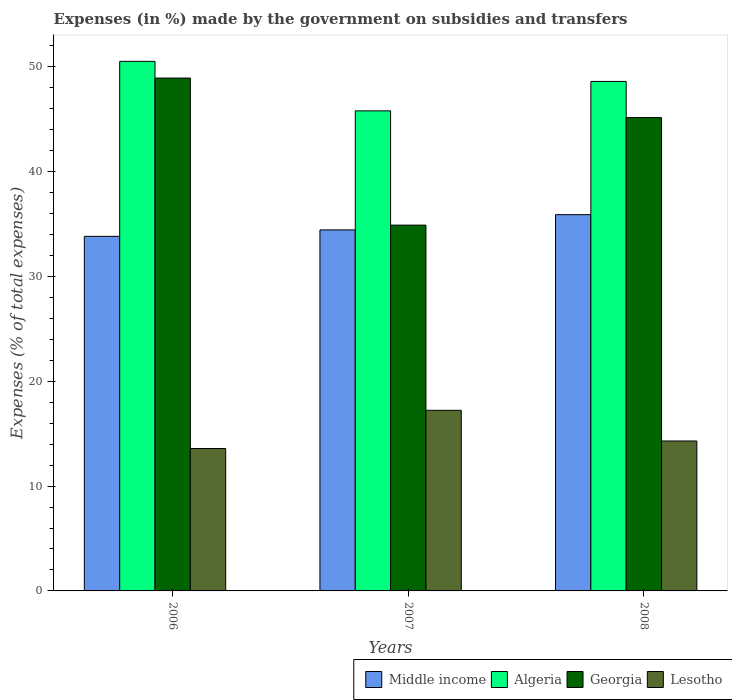How many different coloured bars are there?
Make the answer very short. 4. Are the number of bars per tick equal to the number of legend labels?
Give a very brief answer. Yes. How many bars are there on the 3rd tick from the left?
Offer a terse response. 4. How many bars are there on the 3rd tick from the right?
Keep it short and to the point. 4. What is the percentage of expenses made by the government on subsidies and transfers in Middle income in 2008?
Your response must be concise. 35.88. Across all years, what is the maximum percentage of expenses made by the government on subsidies and transfers in Algeria?
Your answer should be very brief. 50.5. Across all years, what is the minimum percentage of expenses made by the government on subsidies and transfers in Georgia?
Ensure brevity in your answer.  34.89. In which year was the percentage of expenses made by the government on subsidies and transfers in Algeria minimum?
Your answer should be very brief. 2007. What is the total percentage of expenses made by the government on subsidies and transfers in Georgia in the graph?
Keep it short and to the point. 128.94. What is the difference between the percentage of expenses made by the government on subsidies and transfers in Middle income in 2006 and that in 2008?
Make the answer very short. -2.07. What is the difference between the percentage of expenses made by the government on subsidies and transfers in Algeria in 2008 and the percentage of expenses made by the government on subsidies and transfers in Georgia in 2006?
Offer a terse response. -0.32. What is the average percentage of expenses made by the government on subsidies and transfers in Georgia per year?
Keep it short and to the point. 42.98. In the year 2006, what is the difference between the percentage of expenses made by the government on subsidies and transfers in Middle income and percentage of expenses made by the government on subsidies and transfers in Lesotho?
Offer a very short reply. 20.24. In how many years, is the percentage of expenses made by the government on subsidies and transfers in Georgia greater than 10 %?
Make the answer very short. 3. What is the ratio of the percentage of expenses made by the government on subsidies and transfers in Algeria in 2006 to that in 2008?
Your answer should be very brief. 1.04. Is the percentage of expenses made by the government on subsidies and transfers in Georgia in 2007 less than that in 2008?
Provide a short and direct response. Yes. Is the difference between the percentage of expenses made by the government on subsidies and transfers in Middle income in 2006 and 2007 greater than the difference between the percentage of expenses made by the government on subsidies and transfers in Lesotho in 2006 and 2007?
Keep it short and to the point. Yes. What is the difference between the highest and the second highest percentage of expenses made by the government on subsidies and transfers in Lesotho?
Your answer should be compact. 2.92. What is the difference between the highest and the lowest percentage of expenses made by the government on subsidies and transfers in Georgia?
Provide a succinct answer. 14.03. In how many years, is the percentage of expenses made by the government on subsidies and transfers in Georgia greater than the average percentage of expenses made by the government on subsidies and transfers in Georgia taken over all years?
Give a very brief answer. 2. What does the 1st bar from the left in 2008 represents?
Offer a terse response. Middle income. How many years are there in the graph?
Provide a succinct answer. 3. What is the difference between two consecutive major ticks on the Y-axis?
Ensure brevity in your answer.  10. Does the graph contain any zero values?
Provide a succinct answer. No. Does the graph contain grids?
Offer a very short reply. No. How many legend labels are there?
Offer a very short reply. 4. How are the legend labels stacked?
Keep it short and to the point. Horizontal. What is the title of the graph?
Your response must be concise. Expenses (in %) made by the government on subsidies and transfers. What is the label or title of the X-axis?
Your answer should be very brief. Years. What is the label or title of the Y-axis?
Give a very brief answer. Expenses (% of total expenses). What is the Expenses (% of total expenses) of Middle income in 2006?
Your response must be concise. 33.82. What is the Expenses (% of total expenses) in Algeria in 2006?
Your answer should be very brief. 50.5. What is the Expenses (% of total expenses) in Georgia in 2006?
Keep it short and to the point. 48.91. What is the Expenses (% of total expenses) in Lesotho in 2006?
Offer a terse response. 13.58. What is the Expenses (% of total expenses) in Middle income in 2007?
Ensure brevity in your answer.  34.43. What is the Expenses (% of total expenses) of Algeria in 2007?
Offer a very short reply. 45.78. What is the Expenses (% of total expenses) of Georgia in 2007?
Give a very brief answer. 34.89. What is the Expenses (% of total expenses) in Lesotho in 2007?
Your response must be concise. 17.23. What is the Expenses (% of total expenses) in Middle income in 2008?
Provide a short and direct response. 35.88. What is the Expenses (% of total expenses) of Algeria in 2008?
Provide a short and direct response. 48.59. What is the Expenses (% of total expenses) in Georgia in 2008?
Your answer should be very brief. 45.14. What is the Expenses (% of total expenses) of Lesotho in 2008?
Your answer should be compact. 14.3. Across all years, what is the maximum Expenses (% of total expenses) in Middle income?
Provide a short and direct response. 35.88. Across all years, what is the maximum Expenses (% of total expenses) in Algeria?
Keep it short and to the point. 50.5. Across all years, what is the maximum Expenses (% of total expenses) of Georgia?
Your response must be concise. 48.91. Across all years, what is the maximum Expenses (% of total expenses) of Lesotho?
Make the answer very short. 17.23. Across all years, what is the minimum Expenses (% of total expenses) in Middle income?
Provide a short and direct response. 33.82. Across all years, what is the minimum Expenses (% of total expenses) in Algeria?
Offer a terse response. 45.78. Across all years, what is the minimum Expenses (% of total expenses) in Georgia?
Offer a very short reply. 34.89. Across all years, what is the minimum Expenses (% of total expenses) in Lesotho?
Offer a very short reply. 13.58. What is the total Expenses (% of total expenses) of Middle income in the graph?
Give a very brief answer. 104.13. What is the total Expenses (% of total expenses) of Algeria in the graph?
Your answer should be very brief. 144.88. What is the total Expenses (% of total expenses) of Georgia in the graph?
Make the answer very short. 128.94. What is the total Expenses (% of total expenses) of Lesotho in the graph?
Your answer should be compact. 45.1. What is the difference between the Expenses (% of total expenses) in Middle income in 2006 and that in 2007?
Offer a terse response. -0.61. What is the difference between the Expenses (% of total expenses) of Algeria in 2006 and that in 2007?
Your answer should be compact. 4.72. What is the difference between the Expenses (% of total expenses) of Georgia in 2006 and that in 2007?
Make the answer very short. 14.03. What is the difference between the Expenses (% of total expenses) in Lesotho in 2006 and that in 2007?
Your answer should be compact. -3.65. What is the difference between the Expenses (% of total expenses) of Middle income in 2006 and that in 2008?
Make the answer very short. -2.07. What is the difference between the Expenses (% of total expenses) in Algeria in 2006 and that in 2008?
Make the answer very short. 1.91. What is the difference between the Expenses (% of total expenses) in Georgia in 2006 and that in 2008?
Offer a very short reply. 3.77. What is the difference between the Expenses (% of total expenses) in Lesotho in 2006 and that in 2008?
Offer a very short reply. -0.72. What is the difference between the Expenses (% of total expenses) of Middle income in 2007 and that in 2008?
Your answer should be very brief. -1.45. What is the difference between the Expenses (% of total expenses) of Algeria in 2007 and that in 2008?
Offer a very short reply. -2.81. What is the difference between the Expenses (% of total expenses) of Georgia in 2007 and that in 2008?
Ensure brevity in your answer.  -10.26. What is the difference between the Expenses (% of total expenses) of Lesotho in 2007 and that in 2008?
Provide a succinct answer. 2.92. What is the difference between the Expenses (% of total expenses) of Middle income in 2006 and the Expenses (% of total expenses) of Algeria in 2007?
Provide a succinct answer. -11.97. What is the difference between the Expenses (% of total expenses) in Middle income in 2006 and the Expenses (% of total expenses) in Georgia in 2007?
Your answer should be very brief. -1.07. What is the difference between the Expenses (% of total expenses) in Middle income in 2006 and the Expenses (% of total expenses) in Lesotho in 2007?
Give a very brief answer. 16.59. What is the difference between the Expenses (% of total expenses) in Algeria in 2006 and the Expenses (% of total expenses) in Georgia in 2007?
Offer a terse response. 15.62. What is the difference between the Expenses (% of total expenses) in Algeria in 2006 and the Expenses (% of total expenses) in Lesotho in 2007?
Make the answer very short. 33.28. What is the difference between the Expenses (% of total expenses) in Georgia in 2006 and the Expenses (% of total expenses) in Lesotho in 2007?
Ensure brevity in your answer.  31.69. What is the difference between the Expenses (% of total expenses) of Middle income in 2006 and the Expenses (% of total expenses) of Algeria in 2008?
Provide a short and direct response. -14.77. What is the difference between the Expenses (% of total expenses) in Middle income in 2006 and the Expenses (% of total expenses) in Georgia in 2008?
Offer a very short reply. -11.33. What is the difference between the Expenses (% of total expenses) in Middle income in 2006 and the Expenses (% of total expenses) in Lesotho in 2008?
Ensure brevity in your answer.  19.52. What is the difference between the Expenses (% of total expenses) of Algeria in 2006 and the Expenses (% of total expenses) of Georgia in 2008?
Your answer should be very brief. 5.36. What is the difference between the Expenses (% of total expenses) of Algeria in 2006 and the Expenses (% of total expenses) of Lesotho in 2008?
Provide a short and direct response. 36.2. What is the difference between the Expenses (% of total expenses) in Georgia in 2006 and the Expenses (% of total expenses) in Lesotho in 2008?
Offer a very short reply. 34.61. What is the difference between the Expenses (% of total expenses) of Middle income in 2007 and the Expenses (% of total expenses) of Algeria in 2008?
Your answer should be very brief. -14.16. What is the difference between the Expenses (% of total expenses) in Middle income in 2007 and the Expenses (% of total expenses) in Georgia in 2008?
Provide a succinct answer. -10.71. What is the difference between the Expenses (% of total expenses) of Middle income in 2007 and the Expenses (% of total expenses) of Lesotho in 2008?
Your answer should be very brief. 20.13. What is the difference between the Expenses (% of total expenses) of Algeria in 2007 and the Expenses (% of total expenses) of Georgia in 2008?
Keep it short and to the point. 0.64. What is the difference between the Expenses (% of total expenses) of Algeria in 2007 and the Expenses (% of total expenses) of Lesotho in 2008?
Offer a terse response. 31.48. What is the difference between the Expenses (% of total expenses) of Georgia in 2007 and the Expenses (% of total expenses) of Lesotho in 2008?
Provide a short and direct response. 20.59. What is the average Expenses (% of total expenses) in Middle income per year?
Make the answer very short. 34.71. What is the average Expenses (% of total expenses) of Algeria per year?
Offer a terse response. 48.29. What is the average Expenses (% of total expenses) in Georgia per year?
Provide a succinct answer. 42.98. What is the average Expenses (% of total expenses) in Lesotho per year?
Offer a terse response. 15.04. In the year 2006, what is the difference between the Expenses (% of total expenses) of Middle income and Expenses (% of total expenses) of Algeria?
Provide a short and direct response. -16.69. In the year 2006, what is the difference between the Expenses (% of total expenses) in Middle income and Expenses (% of total expenses) in Georgia?
Offer a terse response. -15.1. In the year 2006, what is the difference between the Expenses (% of total expenses) of Middle income and Expenses (% of total expenses) of Lesotho?
Offer a terse response. 20.24. In the year 2006, what is the difference between the Expenses (% of total expenses) of Algeria and Expenses (% of total expenses) of Georgia?
Your answer should be compact. 1.59. In the year 2006, what is the difference between the Expenses (% of total expenses) in Algeria and Expenses (% of total expenses) in Lesotho?
Make the answer very short. 36.92. In the year 2006, what is the difference between the Expenses (% of total expenses) of Georgia and Expenses (% of total expenses) of Lesotho?
Your response must be concise. 35.33. In the year 2007, what is the difference between the Expenses (% of total expenses) of Middle income and Expenses (% of total expenses) of Algeria?
Your answer should be very brief. -11.35. In the year 2007, what is the difference between the Expenses (% of total expenses) in Middle income and Expenses (% of total expenses) in Georgia?
Make the answer very short. -0.46. In the year 2007, what is the difference between the Expenses (% of total expenses) of Middle income and Expenses (% of total expenses) of Lesotho?
Provide a short and direct response. 17.21. In the year 2007, what is the difference between the Expenses (% of total expenses) of Algeria and Expenses (% of total expenses) of Georgia?
Your answer should be very brief. 10.9. In the year 2007, what is the difference between the Expenses (% of total expenses) in Algeria and Expenses (% of total expenses) in Lesotho?
Keep it short and to the point. 28.56. In the year 2007, what is the difference between the Expenses (% of total expenses) in Georgia and Expenses (% of total expenses) in Lesotho?
Offer a terse response. 17.66. In the year 2008, what is the difference between the Expenses (% of total expenses) in Middle income and Expenses (% of total expenses) in Algeria?
Make the answer very short. -12.71. In the year 2008, what is the difference between the Expenses (% of total expenses) in Middle income and Expenses (% of total expenses) in Georgia?
Your answer should be very brief. -9.26. In the year 2008, what is the difference between the Expenses (% of total expenses) in Middle income and Expenses (% of total expenses) in Lesotho?
Provide a succinct answer. 21.58. In the year 2008, what is the difference between the Expenses (% of total expenses) of Algeria and Expenses (% of total expenses) of Georgia?
Offer a terse response. 3.45. In the year 2008, what is the difference between the Expenses (% of total expenses) of Algeria and Expenses (% of total expenses) of Lesotho?
Offer a terse response. 34.29. In the year 2008, what is the difference between the Expenses (% of total expenses) in Georgia and Expenses (% of total expenses) in Lesotho?
Your answer should be very brief. 30.84. What is the ratio of the Expenses (% of total expenses) of Middle income in 2006 to that in 2007?
Make the answer very short. 0.98. What is the ratio of the Expenses (% of total expenses) in Algeria in 2006 to that in 2007?
Offer a terse response. 1.1. What is the ratio of the Expenses (% of total expenses) of Georgia in 2006 to that in 2007?
Offer a terse response. 1.4. What is the ratio of the Expenses (% of total expenses) of Lesotho in 2006 to that in 2007?
Your response must be concise. 0.79. What is the ratio of the Expenses (% of total expenses) in Middle income in 2006 to that in 2008?
Offer a terse response. 0.94. What is the ratio of the Expenses (% of total expenses) of Algeria in 2006 to that in 2008?
Ensure brevity in your answer.  1.04. What is the ratio of the Expenses (% of total expenses) of Georgia in 2006 to that in 2008?
Keep it short and to the point. 1.08. What is the ratio of the Expenses (% of total expenses) in Lesotho in 2006 to that in 2008?
Provide a short and direct response. 0.95. What is the ratio of the Expenses (% of total expenses) of Middle income in 2007 to that in 2008?
Provide a short and direct response. 0.96. What is the ratio of the Expenses (% of total expenses) of Algeria in 2007 to that in 2008?
Provide a short and direct response. 0.94. What is the ratio of the Expenses (% of total expenses) in Georgia in 2007 to that in 2008?
Offer a very short reply. 0.77. What is the ratio of the Expenses (% of total expenses) of Lesotho in 2007 to that in 2008?
Offer a terse response. 1.2. What is the difference between the highest and the second highest Expenses (% of total expenses) of Middle income?
Give a very brief answer. 1.45. What is the difference between the highest and the second highest Expenses (% of total expenses) of Algeria?
Keep it short and to the point. 1.91. What is the difference between the highest and the second highest Expenses (% of total expenses) of Georgia?
Your answer should be very brief. 3.77. What is the difference between the highest and the second highest Expenses (% of total expenses) of Lesotho?
Your response must be concise. 2.92. What is the difference between the highest and the lowest Expenses (% of total expenses) of Middle income?
Give a very brief answer. 2.07. What is the difference between the highest and the lowest Expenses (% of total expenses) in Algeria?
Your response must be concise. 4.72. What is the difference between the highest and the lowest Expenses (% of total expenses) in Georgia?
Ensure brevity in your answer.  14.03. What is the difference between the highest and the lowest Expenses (% of total expenses) in Lesotho?
Offer a very short reply. 3.65. 